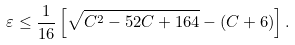Convert formula to latex. <formula><loc_0><loc_0><loc_500><loc_500>\varepsilon \leq \frac { 1 } { 1 6 } \left [ \sqrt { C ^ { 2 } - 5 2 C + 1 6 4 } - ( C + 6 ) \right ] .</formula> 